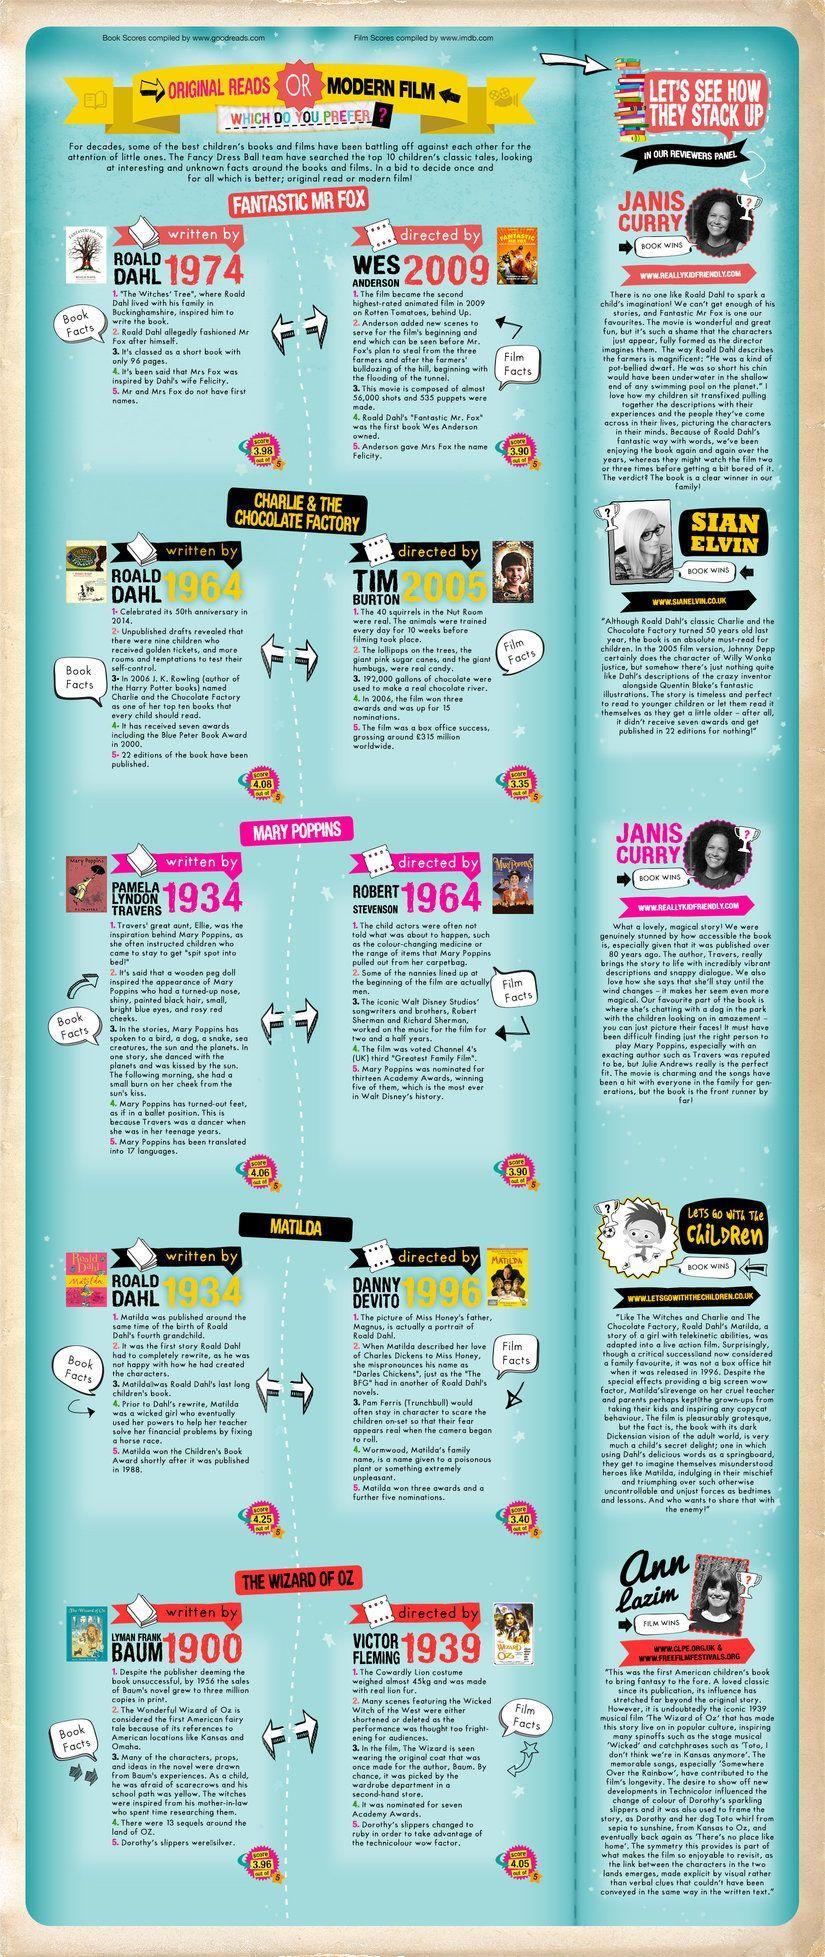Who is the author of 'The Wizard of Oz'?
Answer the question with a short phrase. LYMAN FRANK BAUM Who directed the movie 'Fantastic Mr. Fox'? WES ANDERSON What is the box office collection (in pounds) of the movie 'Charlie & the Chocolate Factory' worldwide? 315 million When was the book 'Mary Poppins' published? 1934 Which movie was directed by Tim Burton in 2005? CHARLIE & THE CHOCOLATE FACTORY 